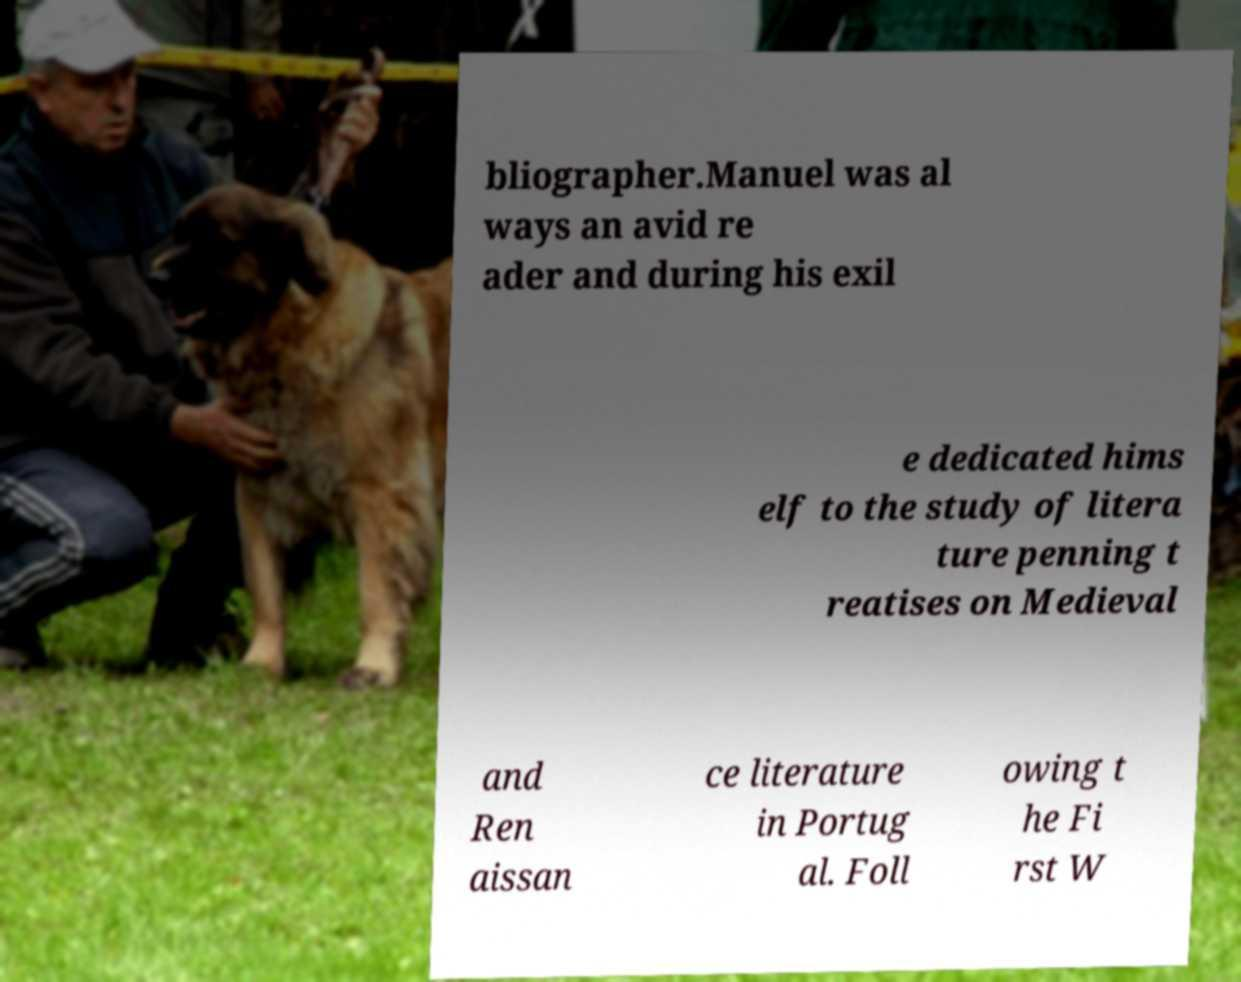For documentation purposes, I need the text within this image transcribed. Could you provide that? bliographer.Manuel was al ways an avid re ader and during his exil e dedicated hims elf to the study of litera ture penning t reatises on Medieval and Ren aissan ce literature in Portug al. Foll owing t he Fi rst W 